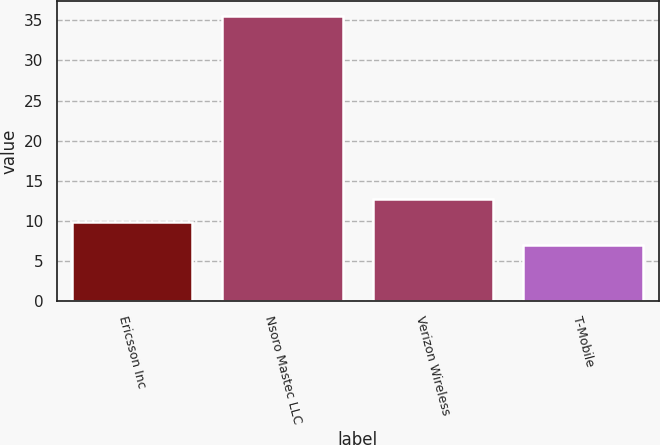Convert chart to OTSL. <chart><loc_0><loc_0><loc_500><loc_500><bar_chart><fcel>Ericsson Inc<fcel>Nsoro Mastec LLC<fcel>Verizon Wireless<fcel>T-Mobile<nl><fcel>9.86<fcel>35.6<fcel>12.72<fcel>7<nl></chart> 